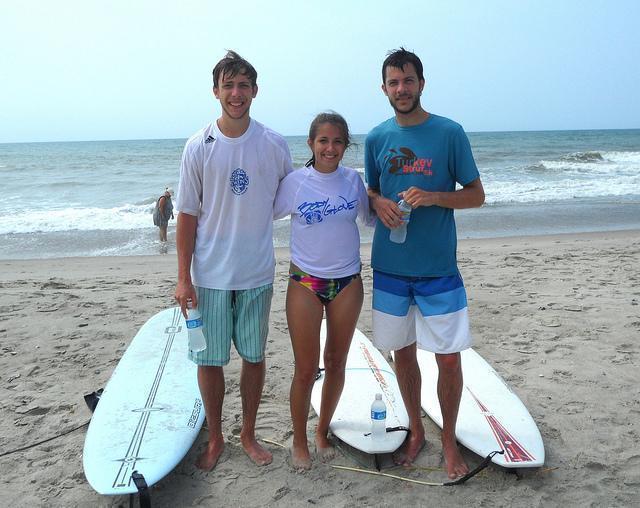How many types of surfboards are there?
Indicate the correct response by choosing from the four available options to answer the question.
Options: Five, nine, three, two. Three. 